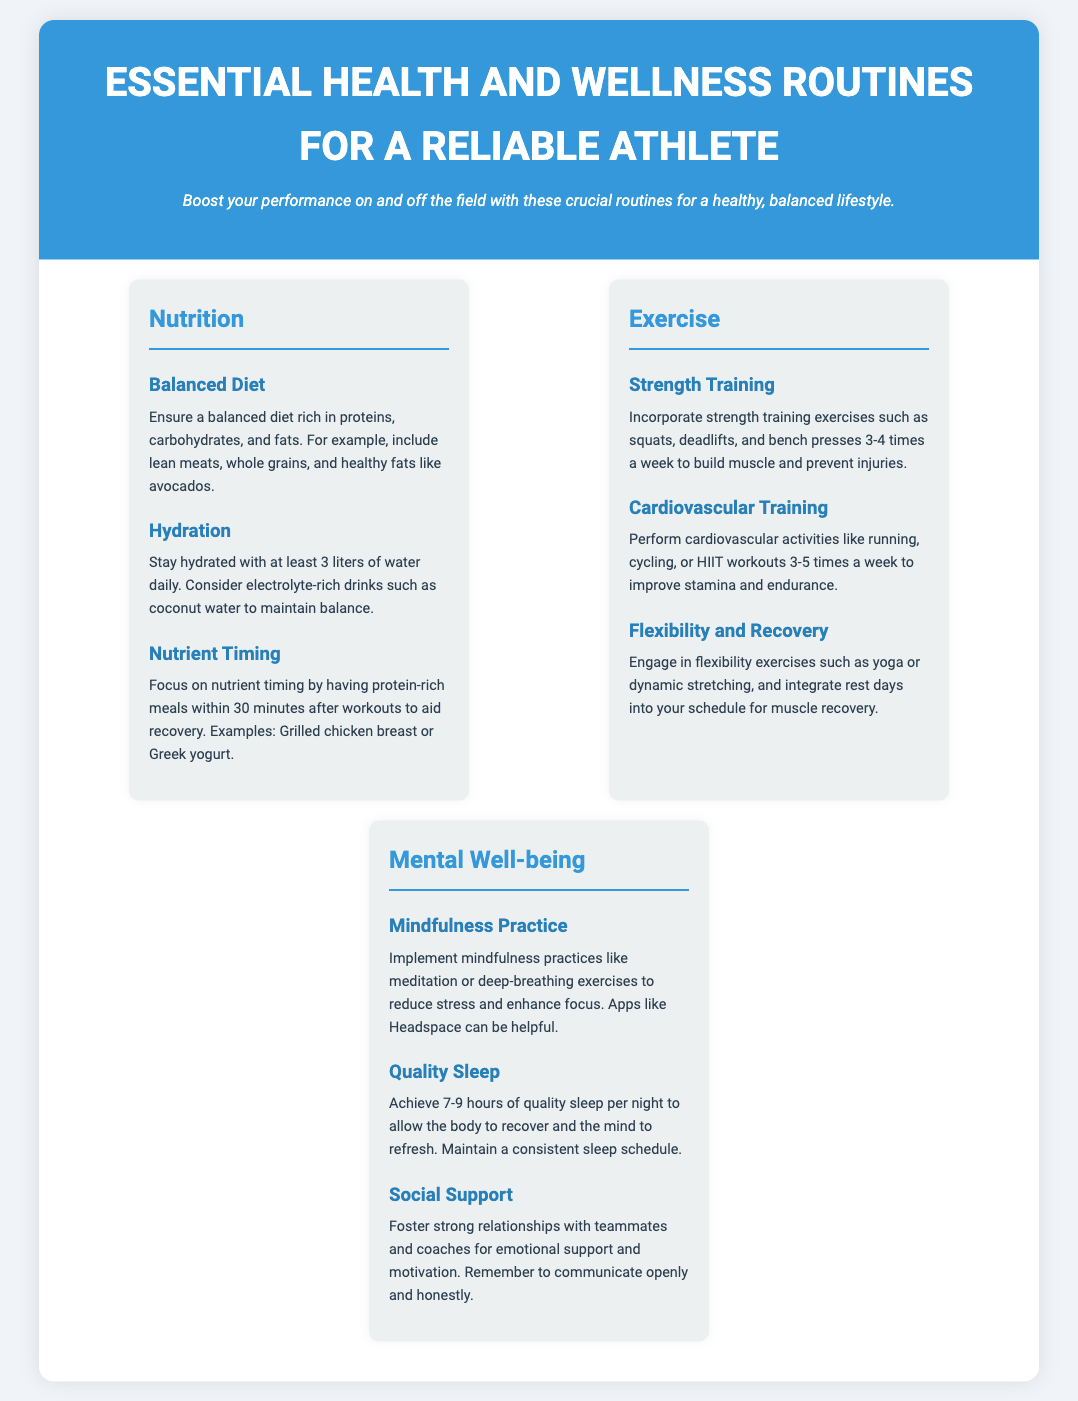What is the title of the document? The title is prominently featured at the top of the document in a larger font.
Answer: Essential Health and Wellness Routines for a Reliable Athlete How many liters of water should an athlete drink daily? The document specifies a hydration recommendation for athletes in the Nutrition section.
Answer: 3 liters What types of training are included in Exercise? The Exercise section lists various types of training that are important for athletes.
Answer: Strength Training, Cardiovascular Training, Flexibility and Recovery What is a recommended mindfulness practice mentioned? The Mental Well-being section includes specific practices for mental health.
Answer: Meditation What is the suggested number of hours of quality sleep per night? This information is provided in the Mental Well-being section of the document.
Answer: 7-9 hours How often should strength training exercises be incorporated? The document provides a frequency recommendation for strength training in the Exercise section.
Answer: 3-4 times a week What food type should be included for nutrient timing? The Nutrition section emphasizes specific food types to be consumed after workouts for recovery.
Answer: Protein-rich meals What do strong relationships provide for athletes? The document mentions the importance of social support in the Mental Well-being section.
Answer: Emotional support and motivation How should hydration be maintained according to the document? The document provides specific strategies for hydration in the Nutrition section.
Answer: Drink electrolyte-rich drinks like coconut water 